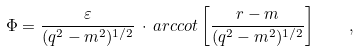<formula> <loc_0><loc_0><loc_500><loc_500>\Phi = \frac { \varepsilon } { ( q ^ { 2 } - m ^ { 2 } ) ^ { 1 / 2 } } \, \cdot \, a r c c o t \left [ \frac { r - m } { ( q ^ { 2 } - m ^ { 2 } ) ^ { 1 / 2 } } \right ] \quad ,</formula> 